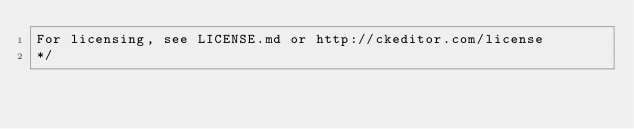Convert code to text. <code><loc_0><loc_0><loc_500><loc_500><_CSS_>For licensing, see LICENSE.md or http://ckeditor.com/license
*/</code> 